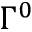<formula> <loc_0><loc_0><loc_500><loc_500>\Gamma ^ { 0 }</formula> 